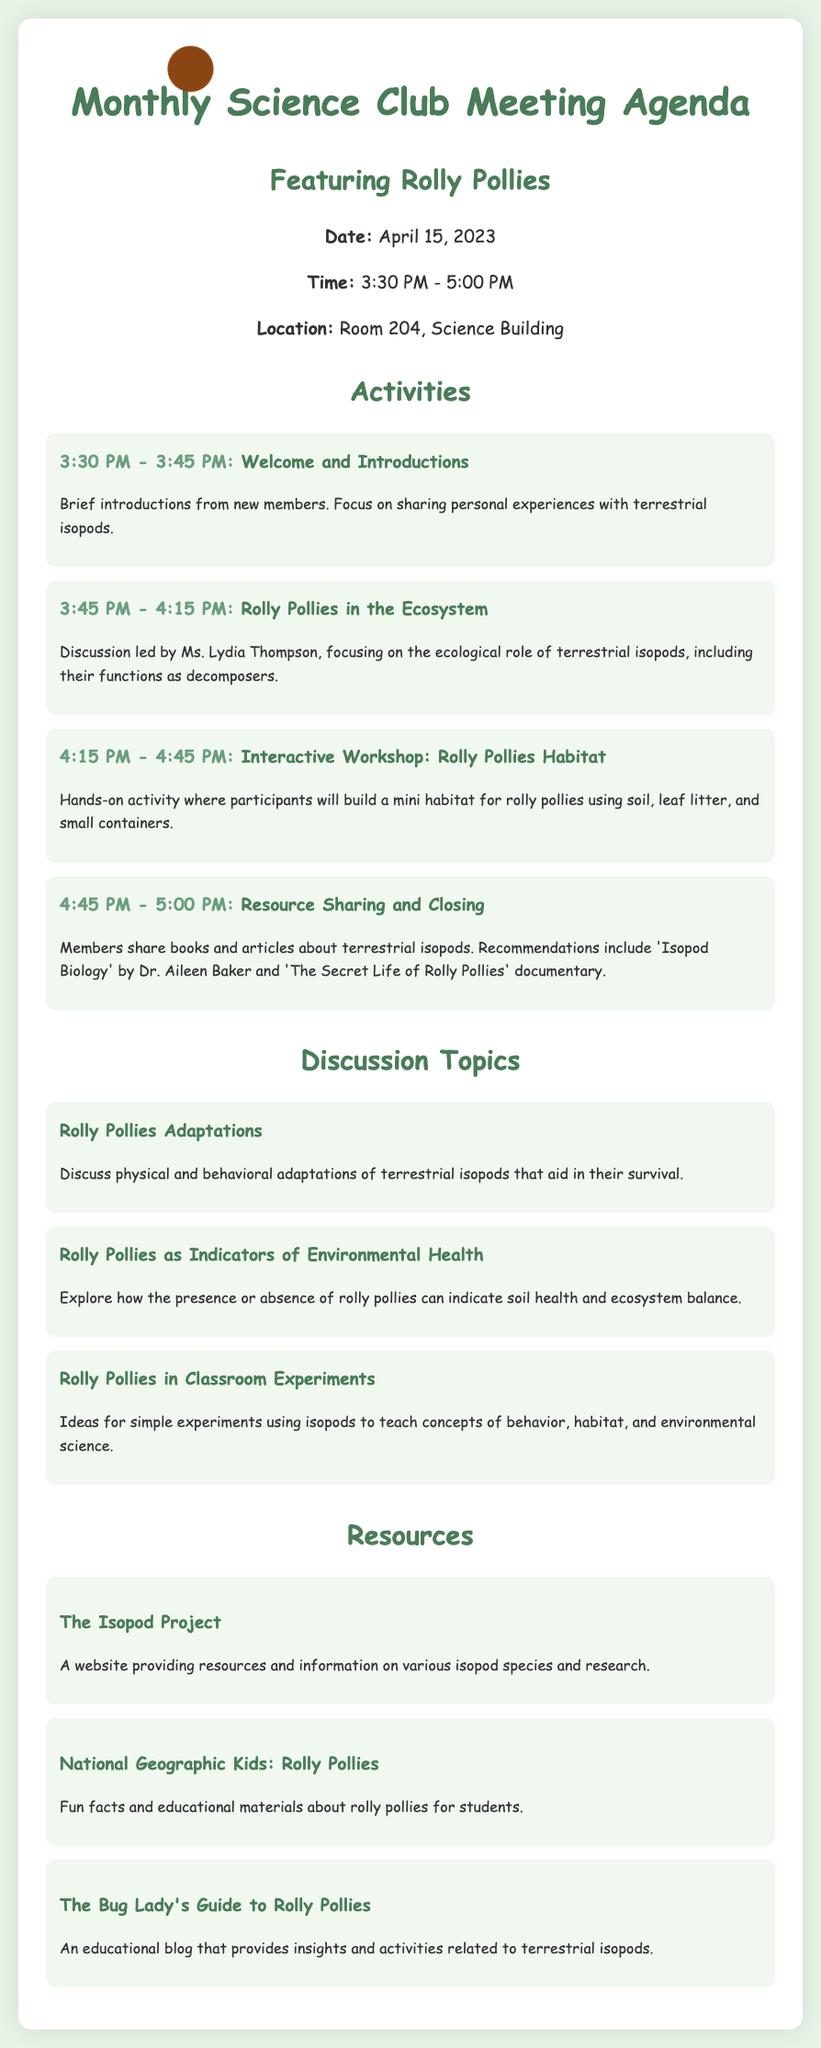What date is the meeting scheduled for? The document states that the meeting is scheduled for April 15, 2023.
Answer: April 15, 2023 Who is leading the discussion on Rolly Pollies in the Ecosystem? The agenda mentions that Ms. Lydia Thompson is responsible for the discussion on this topic.
Answer: Ms. Lydia Thompson What time does the Resource Sharing and Closing activity start? The agenda specifies that this activity begins at 4:45 PM.
Answer: 4:45 PM What is one of the discussion topics listed? The agenda outlines various topics, including adaptations, environmental health, and classroom experiments related to Rolly Pollies.
Answer: Rolly Pollies Adaptations How long is the Interactive Workshop scheduled to last? The agenda indicates that the Interactive Workshop is from 4:15 PM to 4:45 PM, which is a 30-minute duration.
Answer: 30 minutes What type of resource is provided by 'The Isopod Project'? The agenda lists The Isopod Project as a website providing resources and information on isopod species.
Answer: Website How many activities are included in the agenda? There are four distinct activities outlined in the agenda.
Answer: Four What teaching concept can be explored using Rolly Pollies according to the document? The agenda suggests that Rolly Pollies can be used to teach concepts of behavior, habitat, and environmental science.
Answer: Behavioral concepts Which book is recommended in the Resource Sharing section? The agenda recommends 'Isopod Biology' by Dr. Aileen Baker as a resource.
Answer: 'Isopod Biology' by Dr. Aileen Baker 